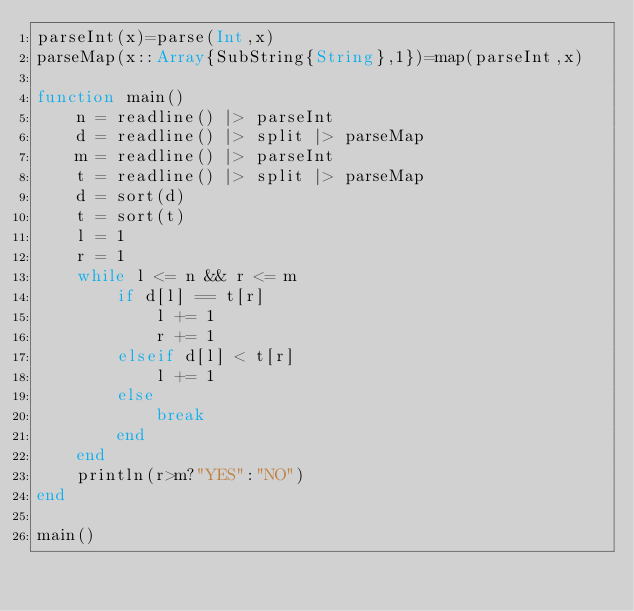<code> <loc_0><loc_0><loc_500><loc_500><_Julia_>parseInt(x)=parse(Int,x)
parseMap(x::Array{SubString{String},1})=map(parseInt,x)

function main()
	n = readline() |> parseInt
	d = readline() |> split |> parseMap
	m = readline() |> parseInt
	t = readline() |> split |> parseMap
	d = sort(d)
	t = sort(t)
	l = 1
	r = 1
	while l <= n && r <= m
		if d[l] == t[r]
			l += 1
			r += 1
		elseif d[l] < t[r]
			l += 1
		else
			break
		end
	end
	println(r>m?"YES":"NO")
end

main()
</code> 